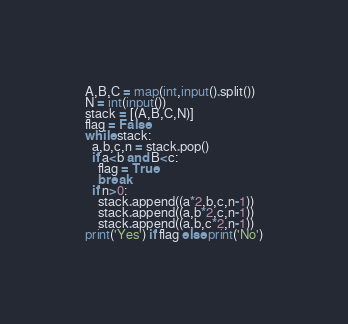<code> <loc_0><loc_0><loc_500><loc_500><_Python_>A,B,C = map(int,input().split())
N = int(input())
stack = [(A,B,C,N)]
flag = False
while stack:
  a,b,c,n = stack.pop()
  if a<b and B<c:
    flag = True
    break
  if n>0:
    stack.append((a*2,b,c,n-1))
    stack.append((a,b*2,c,n-1))
    stack.append((a,b,c*2,n-1))
print('Yes') if flag else print('No')

</code> 